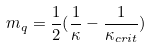Convert formula to latex. <formula><loc_0><loc_0><loc_500><loc_500>m _ { q } = \frac { 1 } { 2 } ( \frac { 1 } { \kappa } - \frac { 1 } { \kappa _ { c r i t } } )</formula> 